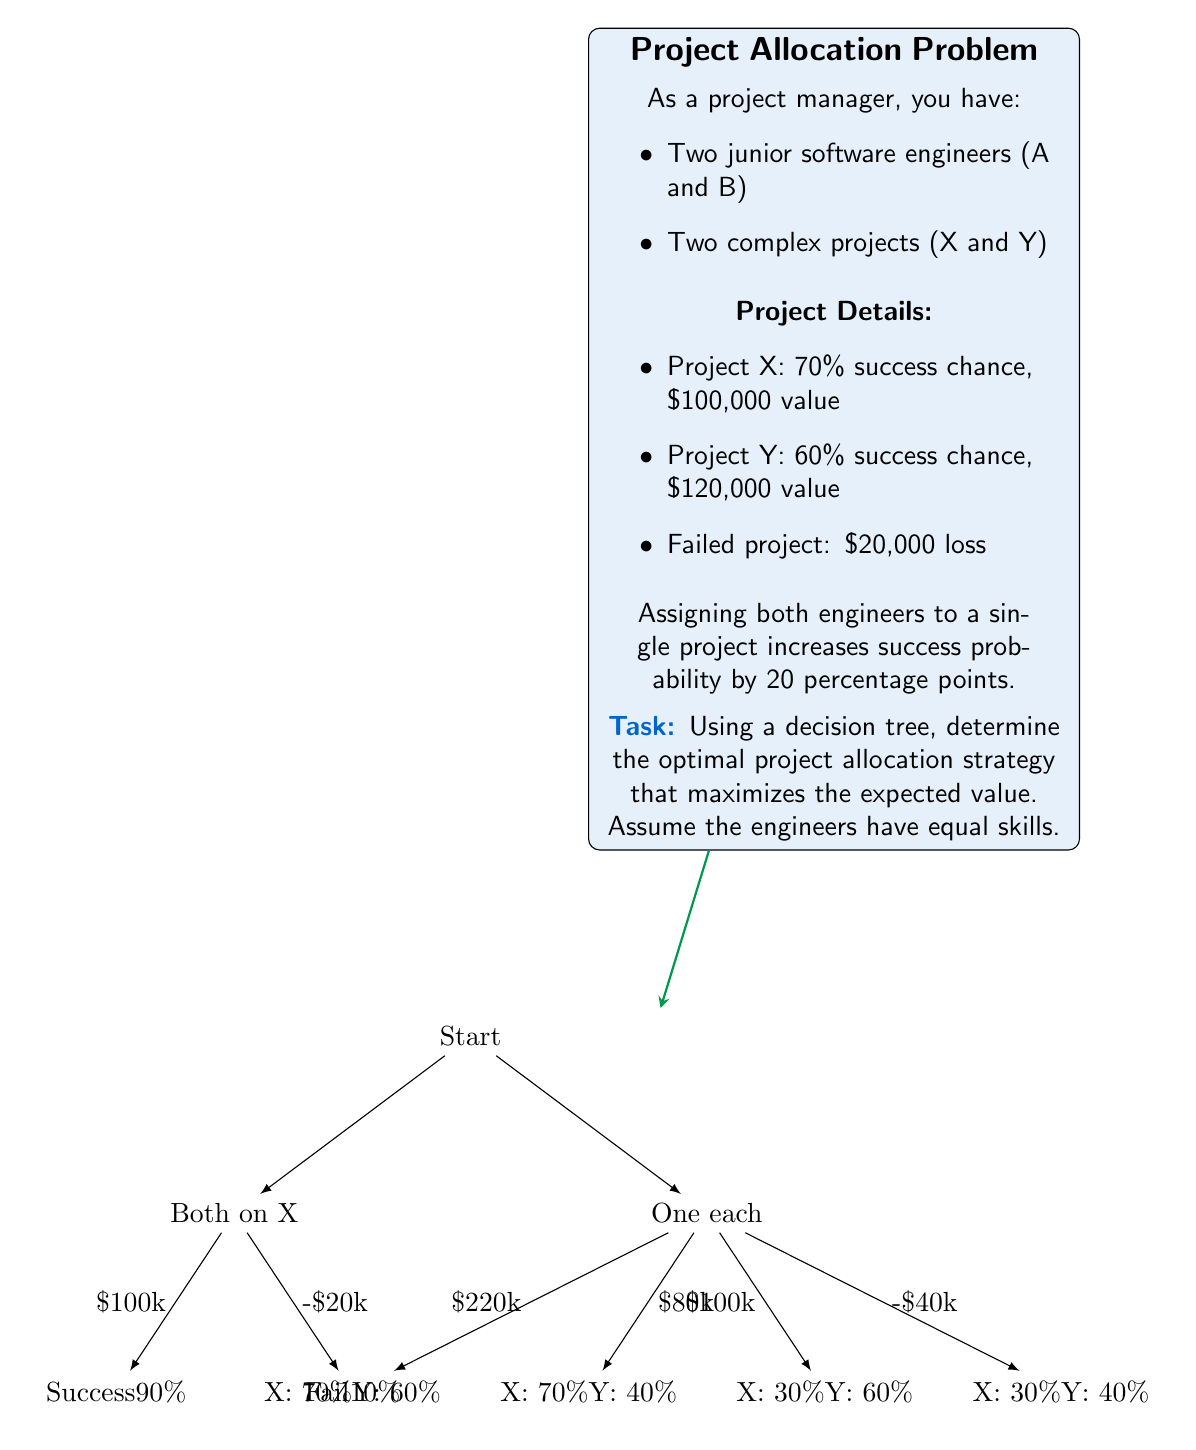Provide a solution to this math problem. Let's approach this problem step-by-step using a decision tree:

1) First, let's calculate the expected values for each project when assigned to a single engineer:

   Project X: $EV_X = 0.7 \times \$100,000 + 0.3 \times (-\$20,000) = \$64,000$
   Project Y: $EV_Y = 0.6 \times \$120,000 + 0.4 \times (-\$20,000) = \$64,000$

2) Now, let's consider the two main strategies:

   a) Assign both engineers to one project
   b) Assign one engineer to each project

3) For strategy (a), we need to calculate the expected value for each project with both engineers:

   Project X: $EV_X^* = 0.9 \times \$100,000 + 0.1 \times (-\$20,000) = \$88,000$
   Project Y: $EV_Y^* = 0.8 \times \$120,000 + 0.2 \times (-\$20,000) = \$92,000$

4) For strategy (b), we sum the individual expected values:

   $EV_{XY} = EV_X + EV_Y = \$64,000 + \$64,000 = \$128,000$

5) Comparing the strategies:

   Strategy (a) - Assign both to Y: $\$92,000$
   Strategy (b) - One each: $\$128,000$

6) The optimal strategy is to assign one engineer to each project, as it yields the highest expected value of $128,000.
Answer: Assign one engineer to each project. 